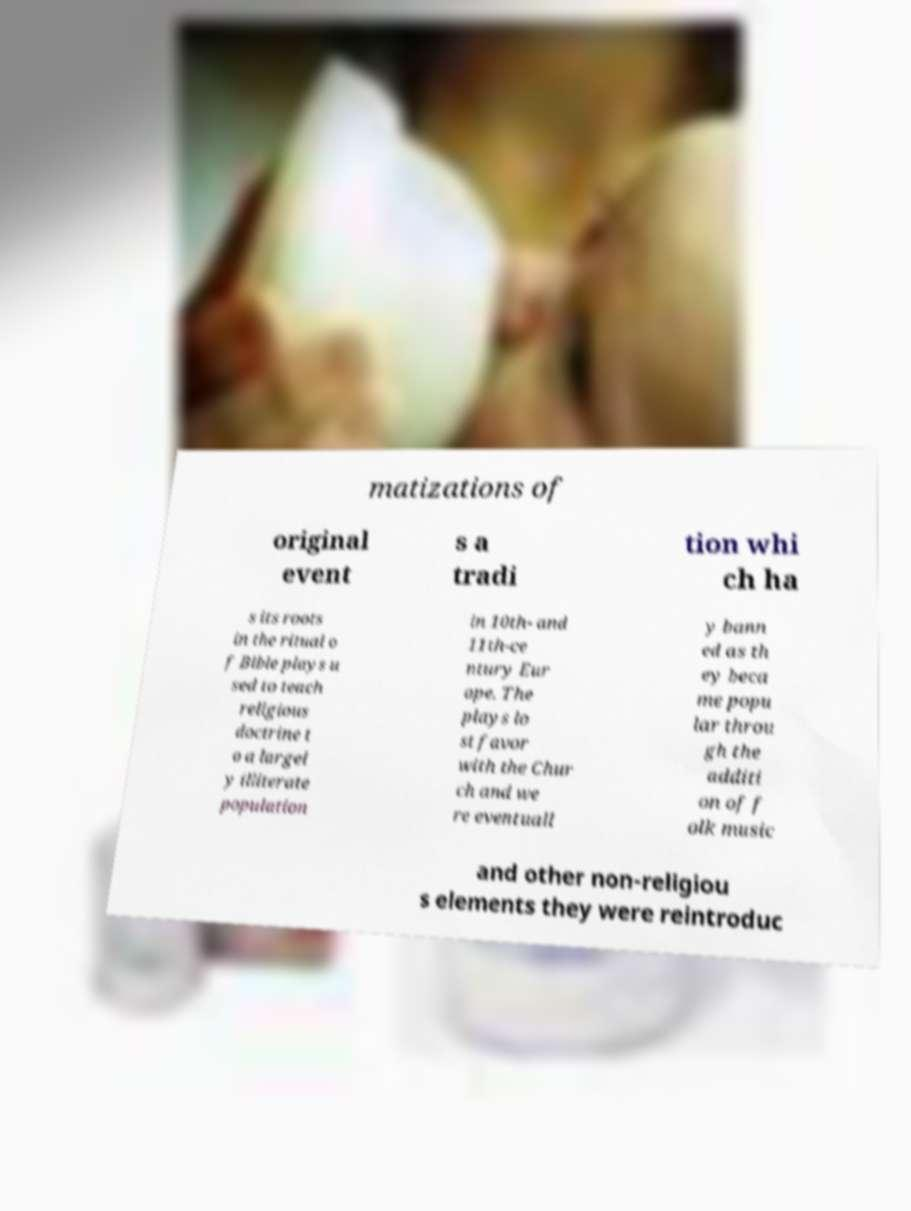Please read and relay the text visible in this image. What does it say? matizations of original event s a tradi tion whi ch ha s its roots in the ritual o f Bible plays u sed to teach religious doctrine t o a largel y illiterate population in 10th- and 11th-ce ntury Eur ope. The plays lo st favor with the Chur ch and we re eventuall y bann ed as th ey beca me popu lar throu gh the additi on of f olk music and other non-religiou s elements they were reintroduc 